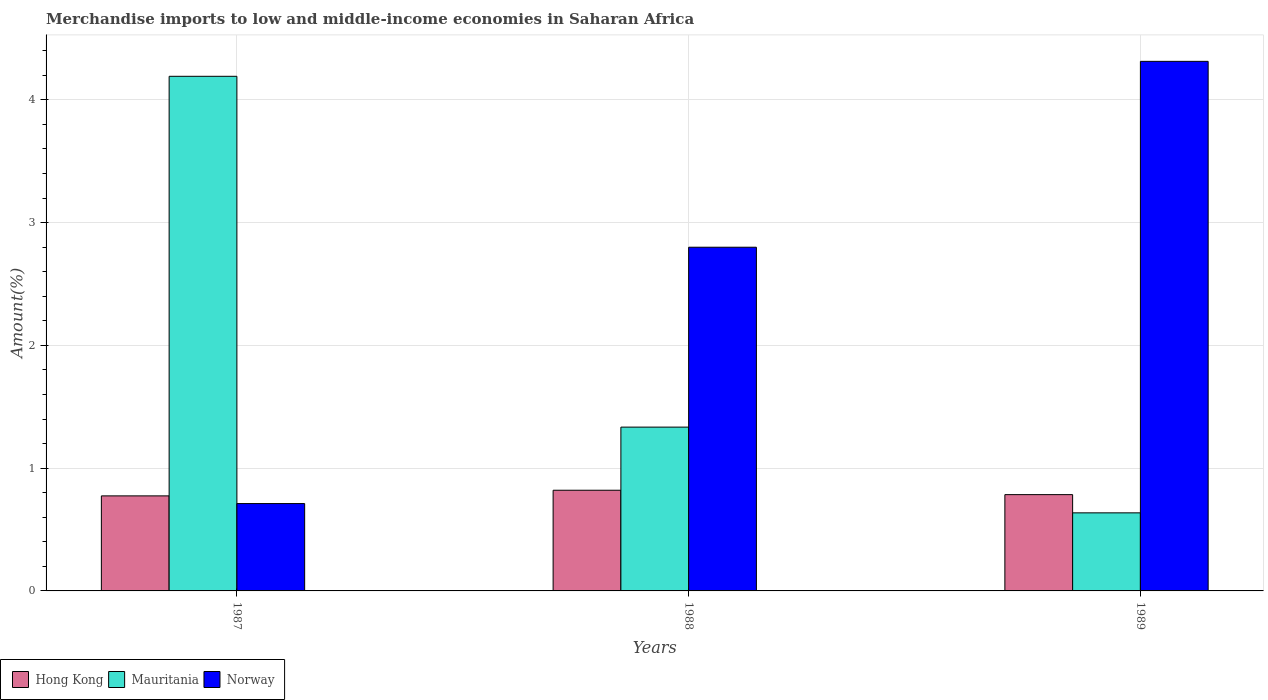How many different coloured bars are there?
Offer a very short reply. 3. How many groups of bars are there?
Your answer should be very brief. 3. How many bars are there on the 3rd tick from the left?
Keep it short and to the point. 3. How many bars are there on the 1st tick from the right?
Make the answer very short. 3. What is the label of the 1st group of bars from the left?
Ensure brevity in your answer.  1987. What is the percentage of amount earned from merchandise imports in Norway in 1988?
Give a very brief answer. 2.8. Across all years, what is the maximum percentage of amount earned from merchandise imports in Norway?
Offer a very short reply. 4.31. Across all years, what is the minimum percentage of amount earned from merchandise imports in Mauritania?
Offer a terse response. 0.64. In which year was the percentage of amount earned from merchandise imports in Hong Kong maximum?
Provide a short and direct response. 1988. In which year was the percentage of amount earned from merchandise imports in Norway minimum?
Your answer should be very brief. 1987. What is the total percentage of amount earned from merchandise imports in Mauritania in the graph?
Your answer should be very brief. 6.16. What is the difference between the percentage of amount earned from merchandise imports in Mauritania in 1987 and that in 1989?
Offer a very short reply. 3.56. What is the difference between the percentage of amount earned from merchandise imports in Norway in 1988 and the percentage of amount earned from merchandise imports in Mauritania in 1987?
Your answer should be compact. -1.39. What is the average percentage of amount earned from merchandise imports in Norway per year?
Provide a succinct answer. 2.61. In the year 1989, what is the difference between the percentage of amount earned from merchandise imports in Mauritania and percentage of amount earned from merchandise imports in Norway?
Offer a terse response. -3.68. What is the ratio of the percentage of amount earned from merchandise imports in Mauritania in 1988 to that in 1989?
Offer a terse response. 2.1. Is the percentage of amount earned from merchandise imports in Mauritania in 1987 less than that in 1989?
Ensure brevity in your answer.  No. Is the difference between the percentage of amount earned from merchandise imports in Mauritania in 1988 and 1989 greater than the difference between the percentage of amount earned from merchandise imports in Norway in 1988 and 1989?
Ensure brevity in your answer.  Yes. What is the difference between the highest and the second highest percentage of amount earned from merchandise imports in Mauritania?
Your answer should be compact. 2.86. What is the difference between the highest and the lowest percentage of amount earned from merchandise imports in Mauritania?
Make the answer very short. 3.56. Is the sum of the percentage of amount earned from merchandise imports in Hong Kong in 1987 and 1988 greater than the maximum percentage of amount earned from merchandise imports in Norway across all years?
Give a very brief answer. No. What does the 2nd bar from the left in 1989 represents?
Provide a succinct answer. Mauritania. What does the 2nd bar from the right in 1989 represents?
Ensure brevity in your answer.  Mauritania. Are all the bars in the graph horizontal?
Make the answer very short. No. How many years are there in the graph?
Make the answer very short. 3. Are the values on the major ticks of Y-axis written in scientific E-notation?
Ensure brevity in your answer.  No. Does the graph contain grids?
Provide a short and direct response. Yes. Where does the legend appear in the graph?
Offer a terse response. Bottom left. How many legend labels are there?
Give a very brief answer. 3. How are the legend labels stacked?
Your answer should be very brief. Horizontal. What is the title of the graph?
Ensure brevity in your answer.  Merchandise imports to low and middle-income economies in Saharan Africa. What is the label or title of the Y-axis?
Ensure brevity in your answer.  Amount(%). What is the Amount(%) of Hong Kong in 1987?
Give a very brief answer. 0.77. What is the Amount(%) of Mauritania in 1987?
Offer a very short reply. 4.19. What is the Amount(%) of Norway in 1987?
Make the answer very short. 0.71. What is the Amount(%) of Hong Kong in 1988?
Offer a terse response. 0.82. What is the Amount(%) in Mauritania in 1988?
Your answer should be compact. 1.33. What is the Amount(%) of Norway in 1988?
Your response must be concise. 2.8. What is the Amount(%) in Hong Kong in 1989?
Offer a terse response. 0.78. What is the Amount(%) in Mauritania in 1989?
Your response must be concise. 0.64. What is the Amount(%) of Norway in 1989?
Make the answer very short. 4.31. Across all years, what is the maximum Amount(%) in Hong Kong?
Your answer should be very brief. 0.82. Across all years, what is the maximum Amount(%) of Mauritania?
Your answer should be compact. 4.19. Across all years, what is the maximum Amount(%) of Norway?
Provide a succinct answer. 4.31. Across all years, what is the minimum Amount(%) of Hong Kong?
Ensure brevity in your answer.  0.77. Across all years, what is the minimum Amount(%) in Mauritania?
Your response must be concise. 0.64. Across all years, what is the minimum Amount(%) in Norway?
Make the answer very short. 0.71. What is the total Amount(%) in Hong Kong in the graph?
Provide a short and direct response. 2.38. What is the total Amount(%) in Mauritania in the graph?
Ensure brevity in your answer.  6.16. What is the total Amount(%) in Norway in the graph?
Keep it short and to the point. 7.83. What is the difference between the Amount(%) in Hong Kong in 1987 and that in 1988?
Your response must be concise. -0.05. What is the difference between the Amount(%) of Mauritania in 1987 and that in 1988?
Offer a terse response. 2.86. What is the difference between the Amount(%) in Norway in 1987 and that in 1988?
Give a very brief answer. -2.09. What is the difference between the Amount(%) in Hong Kong in 1987 and that in 1989?
Your response must be concise. -0.01. What is the difference between the Amount(%) in Mauritania in 1987 and that in 1989?
Your response must be concise. 3.56. What is the difference between the Amount(%) of Norway in 1987 and that in 1989?
Your answer should be compact. -3.6. What is the difference between the Amount(%) of Hong Kong in 1988 and that in 1989?
Offer a very short reply. 0.04. What is the difference between the Amount(%) in Mauritania in 1988 and that in 1989?
Your response must be concise. 0.7. What is the difference between the Amount(%) in Norway in 1988 and that in 1989?
Your answer should be compact. -1.51. What is the difference between the Amount(%) of Hong Kong in 1987 and the Amount(%) of Mauritania in 1988?
Give a very brief answer. -0.56. What is the difference between the Amount(%) in Hong Kong in 1987 and the Amount(%) in Norway in 1988?
Provide a succinct answer. -2.03. What is the difference between the Amount(%) in Mauritania in 1987 and the Amount(%) in Norway in 1988?
Provide a short and direct response. 1.39. What is the difference between the Amount(%) in Hong Kong in 1987 and the Amount(%) in Mauritania in 1989?
Your answer should be very brief. 0.14. What is the difference between the Amount(%) of Hong Kong in 1987 and the Amount(%) of Norway in 1989?
Keep it short and to the point. -3.54. What is the difference between the Amount(%) in Mauritania in 1987 and the Amount(%) in Norway in 1989?
Offer a terse response. -0.12. What is the difference between the Amount(%) of Hong Kong in 1988 and the Amount(%) of Mauritania in 1989?
Provide a succinct answer. 0.18. What is the difference between the Amount(%) in Hong Kong in 1988 and the Amount(%) in Norway in 1989?
Provide a succinct answer. -3.49. What is the difference between the Amount(%) in Mauritania in 1988 and the Amount(%) in Norway in 1989?
Your response must be concise. -2.98. What is the average Amount(%) in Hong Kong per year?
Offer a terse response. 0.79. What is the average Amount(%) of Mauritania per year?
Keep it short and to the point. 2.05. What is the average Amount(%) of Norway per year?
Offer a terse response. 2.61. In the year 1987, what is the difference between the Amount(%) in Hong Kong and Amount(%) in Mauritania?
Your answer should be very brief. -3.42. In the year 1987, what is the difference between the Amount(%) of Hong Kong and Amount(%) of Norway?
Your answer should be compact. 0.06. In the year 1987, what is the difference between the Amount(%) in Mauritania and Amount(%) in Norway?
Your answer should be very brief. 3.48. In the year 1988, what is the difference between the Amount(%) of Hong Kong and Amount(%) of Mauritania?
Keep it short and to the point. -0.51. In the year 1988, what is the difference between the Amount(%) of Hong Kong and Amount(%) of Norway?
Make the answer very short. -1.98. In the year 1988, what is the difference between the Amount(%) in Mauritania and Amount(%) in Norway?
Offer a very short reply. -1.47. In the year 1989, what is the difference between the Amount(%) of Hong Kong and Amount(%) of Mauritania?
Make the answer very short. 0.15. In the year 1989, what is the difference between the Amount(%) of Hong Kong and Amount(%) of Norway?
Ensure brevity in your answer.  -3.53. In the year 1989, what is the difference between the Amount(%) in Mauritania and Amount(%) in Norway?
Ensure brevity in your answer.  -3.68. What is the ratio of the Amount(%) in Hong Kong in 1987 to that in 1988?
Give a very brief answer. 0.94. What is the ratio of the Amount(%) in Mauritania in 1987 to that in 1988?
Make the answer very short. 3.14. What is the ratio of the Amount(%) in Norway in 1987 to that in 1988?
Your answer should be compact. 0.25. What is the ratio of the Amount(%) in Hong Kong in 1987 to that in 1989?
Your answer should be compact. 0.99. What is the ratio of the Amount(%) of Mauritania in 1987 to that in 1989?
Offer a very short reply. 6.59. What is the ratio of the Amount(%) in Norway in 1987 to that in 1989?
Give a very brief answer. 0.17. What is the ratio of the Amount(%) in Hong Kong in 1988 to that in 1989?
Offer a very short reply. 1.05. What is the ratio of the Amount(%) in Mauritania in 1988 to that in 1989?
Keep it short and to the point. 2.1. What is the ratio of the Amount(%) of Norway in 1988 to that in 1989?
Give a very brief answer. 0.65. What is the difference between the highest and the second highest Amount(%) in Hong Kong?
Your answer should be very brief. 0.04. What is the difference between the highest and the second highest Amount(%) in Mauritania?
Make the answer very short. 2.86. What is the difference between the highest and the second highest Amount(%) in Norway?
Offer a very short reply. 1.51. What is the difference between the highest and the lowest Amount(%) of Hong Kong?
Offer a very short reply. 0.05. What is the difference between the highest and the lowest Amount(%) of Mauritania?
Your response must be concise. 3.56. What is the difference between the highest and the lowest Amount(%) in Norway?
Offer a terse response. 3.6. 